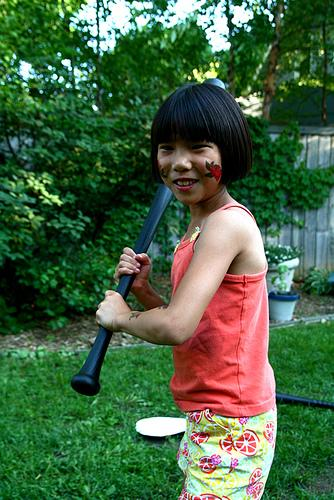What kind of grass can be seen in the image? There is green lush grass and green grass on the ground. Which objects in the image evoke a positive sentiment and why? The smiling girl, bright yellow shorts, and the beautiful green lawn evoke a positive sentiment because they create a joyful and lively atmosphere. Count the number of baseball bats present in the image. There are 3 baseball bats. What type of sport is the young girl playing in the image? The girl is playing baseball. What is the pattern on the girl's yellow shorts? The yellow shorts have a citrus fruit pattern. Provide a description of the girl's tank top, including its color. The girl is wearing a salmon colored spaghetti strap tank top. Identify the type of tattoo present on the girl's face. There is a flower tattoo on the girl's face. How do the fingers on the girl's hand interact with the bat? The fingers are wrapped around the bat, holding it in position. 